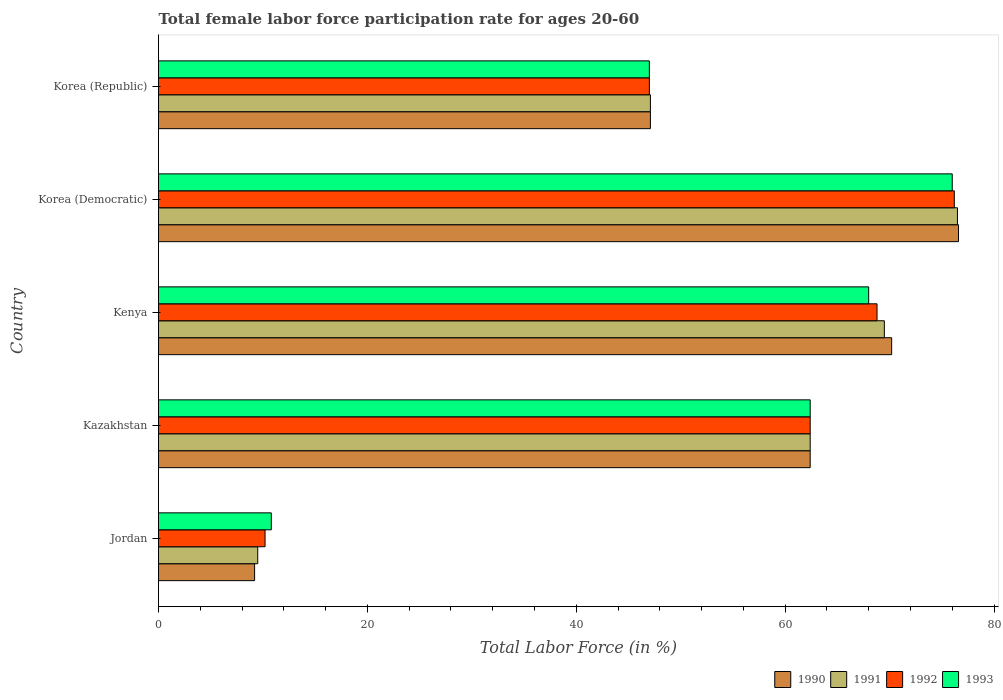How many different coloured bars are there?
Offer a terse response. 4. How many groups of bars are there?
Ensure brevity in your answer.  5. Are the number of bars on each tick of the Y-axis equal?
Give a very brief answer. Yes. How many bars are there on the 3rd tick from the bottom?
Offer a very short reply. 4. What is the label of the 4th group of bars from the top?
Make the answer very short. Kazakhstan. Across all countries, what is the maximum female labor force participation rate in 1991?
Ensure brevity in your answer.  76.5. Across all countries, what is the minimum female labor force participation rate in 1992?
Offer a terse response. 10.2. In which country was the female labor force participation rate in 1990 maximum?
Your response must be concise. Korea (Democratic). In which country was the female labor force participation rate in 1992 minimum?
Offer a terse response. Jordan. What is the total female labor force participation rate in 1991 in the graph?
Provide a succinct answer. 265. What is the difference between the female labor force participation rate in 1991 in Kenya and that in Korea (Republic)?
Give a very brief answer. 22.4. What is the difference between the female labor force participation rate in 1992 in Kenya and the female labor force participation rate in 1990 in Korea (Democratic)?
Make the answer very short. -7.8. What is the average female labor force participation rate in 1993 per country?
Ensure brevity in your answer.  52.84. What is the difference between the female labor force participation rate in 1991 and female labor force participation rate in 1990 in Kenya?
Offer a very short reply. -0.7. In how many countries, is the female labor force participation rate in 1992 greater than 48 %?
Make the answer very short. 3. What is the ratio of the female labor force participation rate in 1993 in Jordan to that in Korea (Republic)?
Keep it short and to the point. 0.23. Is the female labor force participation rate in 1993 in Korea (Democratic) less than that in Korea (Republic)?
Give a very brief answer. No. What is the difference between the highest and the lowest female labor force participation rate in 1993?
Provide a succinct answer. 65.2. In how many countries, is the female labor force participation rate in 1991 greater than the average female labor force participation rate in 1991 taken over all countries?
Your answer should be compact. 3. Is the sum of the female labor force participation rate in 1992 in Kenya and Korea (Democratic) greater than the maximum female labor force participation rate in 1991 across all countries?
Ensure brevity in your answer.  Yes. Is it the case that in every country, the sum of the female labor force participation rate in 1992 and female labor force participation rate in 1991 is greater than the sum of female labor force participation rate in 1993 and female labor force participation rate in 1990?
Make the answer very short. No. Does the graph contain grids?
Your answer should be very brief. No. Where does the legend appear in the graph?
Give a very brief answer. Bottom right. How are the legend labels stacked?
Offer a terse response. Horizontal. What is the title of the graph?
Your response must be concise. Total female labor force participation rate for ages 20-60. What is the label or title of the X-axis?
Keep it short and to the point. Total Labor Force (in %). What is the Total Labor Force (in %) of 1990 in Jordan?
Keep it short and to the point. 9.2. What is the Total Labor Force (in %) of 1992 in Jordan?
Make the answer very short. 10.2. What is the Total Labor Force (in %) of 1993 in Jordan?
Offer a terse response. 10.8. What is the Total Labor Force (in %) in 1990 in Kazakhstan?
Make the answer very short. 62.4. What is the Total Labor Force (in %) of 1991 in Kazakhstan?
Make the answer very short. 62.4. What is the Total Labor Force (in %) of 1992 in Kazakhstan?
Give a very brief answer. 62.4. What is the Total Labor Force (in %) of 1993 in Kazakhstan?
Ensure brevity in your answer.  62.4. What is the Total Labor Force (in %) of 1990 in Kenya?
Make the answer very short. 70.2. What is the Total Labor Force (in %) in 1991 in Kenya?
Give a very brief answer. 69.5. What is the Total Labor Force (in %) in 1992 in Kenya?
Offer a terse response. 68.8. What is the Total Labor Force (in %) in 1993 in Kenya?
Keep it short and to the point. 68. What is the Total Labor Force (in %) of 1990 in Korea (Democratic)?
Provide a succinct answer. 76.6. What is the Total Labor Force (in %) in 1991 in Korea (Democratic)?
Keep it short and to the point. 76.5. What is the Total Labor Force (in %) of 1992 in Korea (Democratic)?
Your response must be concise. 76.2. What is the Total Labor Force (in %) of 1993 in Korea (Democratic)?
Your answer should be very brief. 76. What is the Total Labor Force (in %) of 1990 in Korea (Republic)?
Your response must be concise. 47.1. What is the Total Labor Force (in %) in 1991 in Korea (Republic)?
Offer a very short reply. 47.1. Across all countries, what is the maximum Total Labor Force (in %) of 1990?
Offer a very short reply. 76.6. Across all countries, what is the maximum Total Labor Force (in %) of 1991?
Provide a short and direct response. 76.5. Across all countries, what is the maximum Total Labor Force (in %) in 1992?
Make the answer very short. 76.2. Across all countries, what is the minimum Total Labor Force (in %) of 1990?
Ensure brevity in your answer.  9.2. Across all countries, what is the minimum Total Labor Force (in %) in 1992?
Your answer should be compact. 10.2. Across all countries, what is the minimum Total Labor Force (in %) in 1993?
Offer a very short reply. 10.8. What is the total Total Labor Force (in %) in 1990 in the graph?
Ensure brevity in your answer.  265.5. What is the total Total Labor Force (in %) in 1991 in the graph?
Offer a terse response. 265. What is the total Total Labor Force (in %) of 1992 in the graph?
Your response must be concise. 264.6. What is the total Total Labor Force (in %) of 1993 in the graph?
Make the answer very short. 264.2. What is the difference between the Total Labor Force (in %) in 1990 in Jordan and that in Kazakhstan?
Offer a very short reply. -53.2. What is the difference between the Total Labor Force (in %) in 1991 in Jordan and that in Kazakhstan?
Offer a very short reply. -52.9. What is the difference between the Total Labor Force (in %) in 1992 in Jordan and that in Kazakhstan?
Ensure brevity in your answer.  -52.2. What is the difference between the Total Labor Force (in %) in 1993 in Jordan and that in Kazakhstan?
Give a very brief answer. -51.6. What is the difference between the Total Labor Force (in %) of 1990 in Jordan and that in Kenya?
Offer a very short reply. -61. What is the difference between the Total Labor Force (in %) of 1991 in Jordan and that in Kenya?
Provide a succinct answer. -60. What is the difference between the Total Labor Force (in %) of 1992 in Jordan and that in Kenya?
Your response must be concise. -58.6. What is the difference between the Total Labor Force (in %) of 1993 in Jordan and that in Kenya?
Provide a short and direct response. -57.2. What is the difference between the Total Labor Force (in %) of 1990 in Jordan and that in Korea (Democratic)?
Give a very brief answer. -67.4. What is the difference between the Total Labor Force (in %) of 1991 in Jordan and that in Korea (Democratic)?
Your answer should be very brief. -67. What is the difference between the Total Labor Force (in %) of 1992 in Jordan and that in Korea (Democratic)?
Make the answer very short. -66. What is the difference between the Total Labor Force (in %) in 1993 in Jordan and that in Korea (Democratic)?
Your answer should be very brief. -65.2. What is the difference between the Total Labor Force (in %) of 1990 in Jordan and that in Korea (Republic)?
Your answer should be very brief. -37.9. What is the difference between the Total Labor Force (in %) of 1991 in Jordan and that in Korea (Republic)?
Provide a short and direct response. -37.6. What is the difference between the Total Labor Force (in %) of 1992 in Jordan and that in Korea (Republic)?
Your response must be concise. -36.8. What is the difference between the Total Labor Force (in %) of 1993 in Jordan and that in Korea (Republic)?
Your answer should be compact. -36.2. What is the difference between the Total Labor Force (in %) of 1991 in Kazakhstan and that in Korea (Democratic)?
Offer a very short reply. -14.1. What is the difference between the Total Labor Force (in %) in 1992 in Kazakhstan and that in Korea (Democratic)?
Provide a succinct answer. -13.8. What is the difference between the Total Labor Force (in %) in 1993 in Kazakhstan and that in Korea (Democratic)?
Provide a succinct answer. -13.6. What is the difference between the Total Labor Force (in %) in 1991 in Kazakhstan and that in Korea (Republic)?
Your response must be concise. 15.3. What is the difference between the Total Labor Force (in %) in 1992 in Kazakhstan and that in Korea (Republic)?
Ensure brevity in your answer.  15.4. What is the difference between the Total Labor Force (in %) in 1990 in Kenya and that in Korea (Democratic)?
Your answer should be compact. -6.4. What is the difference between the Total Labor Force (in %) in 1993 in Kenya and that in Korea (Democratic)?
Keep it short and to the point. -8. What is the difference between the Total Labor Force (in %) of 1990 in Kenya and that in Korea (Republic)?
Offer a terse response. 23.1. What is the difference between the Total Labor Force (in %) of 1991 in Kenya and that in Korea (Republic)?
Make the answer very short. 22.4. What is the difference between the Total Labor Force (in %) of 1992 in Kenya and that in Korea (Republic)?
Your answer should be compact. 21.8. What is the difference between the Total Labor Force (in %) of 1990 in Korea (Democratic) and that in Korea (Republic)?
Your answer should be compact. 29.5. What is the difference between the Total Labor Force (in %) of 1991 in Korea (Democratic) and that in Korea (Republic)?
Offer a very short reply. 29.4. What is the difference between the Total Labor Force (in %) in 1992 in Korea (Democratic) and that in Korea (Republic)?
Ensure brevity in your answer.  29.2. What is the difference between the Total Labor Force (in %) of 1993 in Korea (Democratic) and that in Korea (Republic)?
Your answer should be compact. 29. What is the difference between the Total Labor Force (in %) in 1990 in Jordan and the Total Labor Force (in %) in 1991 in Kazakhstan?
Your response must be concise. -53.2. What is the difference between the Total Labor Force (in %) in 1990 in Jordan and the Total Labor Force (in %) in 1992 in Kazakhstan?
Your answer should be very brief. -53.2. What is the difference between the Total Labor Force (in %) in 1990 in Jordan and the Total Labor Force (in %) in 1993 in Kazakhstan?
Ensure brevity in your answer.  -53.2. What is the difference between the Total Labor Force (in %) in 1991 in Jordan and the Total Labor Force (in %) in 1992 in Kazakhstan?
Provide a short and direct response. -52.9. What is the difference between the Total Labor Force (in %) of 1991 in Jordan and the Total Labor Force (in %) of 1993 in Kazakhstan?
Provide a succinct answer. -52.9. What is the difference between the Total Labor Force (in %) in 1992 in Jordan and the Total Labor Force (in %) in 1993 in Kazakhstan?
Offer a terse response. -52.2. What is the difference between the Total Labor Force (in %) of 1990 in Jordan and the Total Labor Force (in %) of 1991 in Kenya?
Keep it short and to the point. -60.3. What is the difference between the Total Labor Force (in %) of 1990 in Jordan and the Total Labor Force (in %) of 1992 in Kenya?
Your response must be concise. -59.6. What is the difference between the Total Labor Force (in %) in 1990 in Jordan and the Total Labor Force (in %) in 1993 in Kenya?
Ensure brevity in your answer.  -58.8. What is the difference between the Total Labor Force (in %) in 1991 in Jordan and the Total Labor Force (in %) in 1992 in Kenya?
Your answer should be compact. -59.3. What is the difference between the Total Labor Force (in %) of 1991 in Jordan and the Total Labor Force (in %) of 1993 in Kenya?
Provide a succinct answer. -58.5. What is the difference between the Total Labor Force (in %) of 1992 in Jordan and the Total Labor Force (in %) of 1993 in Kenya?
Your answer should be very brief. -57.8. What is the difference between the Total Labor Force (in %) of 1990 in Jordan and the Total Labor Force (in %) of 1991 in Korea (Democratic)?
Offer a very short reply. -67.3. What is the difference between the Total Labor Force (in %) in 1990 in Jordan and the Total Labor Force (in %) in 1992 in Korea (Democratic)?
Your response must be concise. -67. What is the difference between the Total Labor Force (in %) of 1990 in Jordan and the Total Labor Force (in %) of 1993 in Korea (Democratic)?
Give a very brief answer. -66.8. What is the difference between the Total Labor Force (in %) of 1991 in Jordan and the Total Labor Force (in %) of 1992 in Korea (Democratic)?
Keep it short and to the point. -66.7. What is the difference between the Total Labor Force (in %) in 1991 in Jordan and the Total Labor Force (in %) in 1993 in Korea (Democratic)?
Give a very brief answer. -66.5. What is the difference between the Total Labor Force (in %) in 1992 in Jordan and the Total Labor Force (in %) in 1993 in Korea (Democratic)?
Ensure brevity in your answer.  -65.8. What is the difference between the Total Labor Force (in %) of 1990 in Jordan and the Total Labor Force (in %) of 1991 in Korea (Republic)?
Your answer should be compact. -37.9. What is the difference between the Total Labor Force (in %) in 1990 in Jordan and the Total Labor Force (in %) in 1992 in Korea (Republic)?
Your response must be concise. -37.8. What is the difference between the Total Labor Force (in %) of 1990 in Jordan and the Total Labor Force (in %) of 1993 in Korea (Republic)?
Your response must be concise. -37.8. What is the difference between the Total Labor Force (in %) in 1991 in Jordan and the Total Labor Force (in %) in 1992 in Korea (Republic)?
Keep it short and to the point. -37.5. What is the difference between the Total Labor Force (in %) of 1991 in Jordan and the Total Labor Force (in %) of 1993 in Korea (Republic)?
Provide a succinct answer. -37.5. What is the difference between the Total Labor Force (in %) in 1992 in Jordan and the Total Labor Force (in %) in 1993 in Korea (Republic)?
Your response must be concise. -36.8. What is the difference between the Total Labor Force (in %) of 1990 in Kazakhstan and the Total Labor Force (in %) of 1992 in Kenya?
Your answer should be compact. -6.4. What is the difference between the Total Labor Force (in %) in 1990 in Kazakhstan and the Total Labor Force (in %) in 1993 in Kenya?
Offer a very short reply. -5.6. What is the difference between the Total Labor Force (in %) of 1991 in Kazakhstan and the Total Labor Force (in %) of 1992 in Kenya?
Offer a terse response. -6.4. What is the difference between the Total Labor Force (in %) in 1992 in Kazakhstan and the Total Labor Force (in %) in 1993 in Kenya?
Ensure brevity in your answer.  -5.6. What is the difference between the Total Labor Force (in %) of 1990 in Kazakhstan and the Total Labor Force (in %) of 1991 in Korea (Democratic)?
Provide a short and direct response. -14.1. What is the difference between the Total Labor Force (in %) of 1991 in Kazakhstan and the Total Labor Force (in %) of 1992 in Korea (Democratic)?
Your answer should be very brief. -13.8. What is the difference between the Total Labor Force (in %) of 1991 in Kazakhstan and the Total Labor Force (in %) of 1993 in Korea (Democratic)?
Provide a succinct answer. -13.6. What is the difference between the Total Labor Force (in %) in 1990 in Kazakhstan and the Total Labor Force (in %) in 1991 in Korea (Republic)?
Your answer should be compact. 15.3. What is the difference between the Total Labor Force (in %) in 1990 in Kazakhstan and the Total Labor Force (in %) in 1992 in Korea (Republic)?
Make the answer very short. 15.4. What is the difference between the Total Labor Force (in %) of 1991 in Kazakhstan and the Total Labor Force (in %) of 1992 in Korea (Republic)?
Your answer should be compact. 15.4. What is the difference between the Total Labor Force (in %) in 1991 in Kazakhstan and the Total Labor Force (in %) in 1993 in Korea (Republic)?
Provide a succinct answer. 15.4. What is the difference between the Total Labor Force (in %) in 1992 in Kazakhstan and the Total Labor Force (in %) in 1993 in Korea (Republic)?
Your response must be concise. 15.4. What is the difference between the Total Labor Force (in %) in 1990 in Kenya and the Total Labor Force (in %) in 1991 in Korea (Democratic)?
Ensure brevity in your answer.  -6.3. What is the difference between the Total Labor Force (in %) in 1990 in Kenya and the Total Labor Force (in %) in 1993 in Korea (Democratic)?
Make the answer very short. -5.8. What is the difference between the Total Labor Force (in %) in 1992 in Kenya and the Total Labor Force (in %) in 1993 in Korea (Democratic)?
Keep it short and to the point. -7.2. What is the difference between the Total Labor Force (in %) in 1990 in Kenya and the Total Labor Force (in %) in 1991 in Korea (Republic)?
Ensure brevity in your answer.  23.1. What is the difference between the Total Labor Force (in %) of 1990 in Kenya and the Total Labor Force (in %) of 1992 in Korea (Republic)?
Provide a short and direct response. 23.2. What is the difference between the Total Labor Force (in %) of 1990 in Kenya and the Total Labor Force (in %) of 1993 in Korea (Republic)?
Provide a short and direct response. 23.2. What is the difference between the Total Labor Force (in %) of 1991 in Kenya and the Total Labor Force (in %) of 1992 in Korea (Republic)?
Ensure brevity in your answer.  22.5. What is the difference between the Total Labor Force (in %) of 1991 in Kenya and the Total Labor Force (in %) of 1993 in Korea (Republic)?
Provide a short and direct response. 22.5. What is the difference between the Total Labor Force (in %) of 1992 in Kenya and the Total Labor Force (in %) of 1993 in Korea (Republic)?
Make the answer very short. 21.8. What is the difference between the Total Labor Force (in %) of 1990 in Korea (Democratic) and the Total Labor Force (in %) of 1991 in Korea (Republic)?
Offer a terse response. 29.5. What is the difference between the Total Labor Force (in %) in 1990 in Korea (Democratic) and the Total Labor Force (in %) in 1992 in Korea (Republic)?
Give a very brief answer. 29.6. What is the difference between the Total Labor Force (in %) in 1990 in Korea (Democratic) and the Total Labor Force (in %) in 1993 in Korea (Republic)?
Ensure brevity in your answer.  29.6. What is the difference between the Total Labor Force (in %) of 1991 in Korea (Democratic) and the Total Labor Force (in %) of 1992 in Korea (Republic)?
Your response must be concise. 29.5. What is the difference between the Total Labor Force (in %) of 1991 in Korea (Democratic) and the Total Labor Force (in %) of 1993 in Korea (Republic)?
Your response must be concise. 29.5. What is the difference between the Total Labor Force (in %) of 1992 in Korea (Democratic) and the Total Labor Force (in %) of 1993 in Korea (Republic)?
Give a very brief answer. 29.2. What is the average Total Labor Force (in %) of 1990 per country?
Provide a short and direct response. 53.1. What is the average Total Labor Force (in %) in 1992 per country?
Ensure brevity in your answer.  52.92. What is the average Total Labor Force (in %) in 1993 per country?
Ensure brevity in your answer.  52.84. What is the difference between the Total Labor Force (in %) of 1990 and Total Labor Force (in %) of 1991 in Jordan?
Offer a terse response. -0.3. What is the difference between the Total Labor Force (in %) of 1990 and Total Labor Force (in %) of 1993 in Jordan?
Ensure brevity in your answer.  -1.6. What is the difference between the Total Labor Force (in %) in 1991 and Total Labor Force (in %) in 1992 in Jordan?
Provide a succinct answer. -0.7. What is the difference between the Total Labor Force (in %) of 1990 and Total Labor Force (in %) of 1992 in Kazakhstan?
Provide a succinct answer. 0. What is the difference between the Total Labor Force (in %) of 1990 and Total Labor Force (in %) of 1993 in Kazakhstan?
Give a very brief answer. 0. What is the difference between the Total Labor Force (in %) of 1991 and Total Labor Force (in %) of 1992 in Kazakhstan?
Your answer should be very brief. 0. What is the difference between the Total Labor Force (in %) of 1991 and Total Labor Force (in %) of 1993 in Kazakhstan?
Your answer should be very brief. 0. What is the difference between the Total Labor Force (in %) in 1990 and Total Labor Force (in %) in 1991 in Kenya?
Ensure brevity in your answer.  0.7. What is the difference between the Total Labor Force (in %) of 1990 and Total Labor Force (in %) of 1992 in Kenya?
Offer a terse response. 1.4. What is the difference between the Total Labor Force (in %) of 1990 and Total Labor Force (in %) of 1993 in Kenya?
Give a very brief answer. 2.2. What is the difference between the Total Labor Force (in %) in 1991 and Total Labor Force (in %) in 1992 in Kenya?
Give a very brief answer. 0.7. What is the difference between the Total Labor Force (in %) in 1992 and Total Labor Force (in %) in 1993 in Kenya?
Give a very brief answer. 0.8. What is the difference between the Total Labor Force (in %) in 1990 and Total Labor Force (in %) in 1992 in Korea (Democratic)?
Keep it short and to the point. 0.4. What is the difference between the Total Labor Force (in %) of 1990 and Total Labor Force (in %) of 1993 in Korea (Democratic)?
Your answer should be very brief. 0.6. What is the difference between the Total Labor Force (in %) in 1990 and Total Labor Force (in %) in 1991 in Korea (Republic)?
Offer a terse response. 0. What is the difference between the Total Labor Force (in %) in 1990 and Total Labor Force (in %) in 1993 in Korea (Republic)?
Your response must be concise. 0.1. What is the difference between the Total Labor Force (in %) of 1991 and Total Labor Force (in %) of 1992 in Korea (Republic)?
Give a very brief answer. 0.1. What is the ratio of the Total Labor Force (in %) of 1990 in Jordan to that in Kazakhstan?
Offer a terse response. 0.15. What is the ratio of the Total Labor Force (in %) in 1991 in Jordan to that in Kazakhstan?
Your response must be concise. 0.15. What is the ratio of the Total Labor Force (in %) in 1992 in Jordan to that in Kazakhstan?
Provide a short and direct response. 0.16. What is the ratio of the Total Labor Force (in %) of 1993 in Jordan to that in Kazakhstan?
Give a very brief answer. 0.17. What is the ratio of the Total Labor Force (in %) of 1990 in Jordan to that in Kenya?
Provide a short and direct response. 0.13. What is the ratio of the Total Labor Force (in %) of 1991 in Jordan to that in Kenya?
Provide a short and direct response. 0.14. What is the ratio of the Total Labor Force (in %) in 1992 in Jordan to that in Kenya?
Provide a succinct answer. 0.15. What is the ratio of the Total Labor Force (in %) in 1993 in Jordan to that in Kenya?
Your answer should be very brief. 0.16. What is the ratio of the Total Labor Force (in %) of 1990 in Jordan to that in Korea (Democratic)?
Ensure brevity in your answer.  0.12. What is the ratio of the Total Labor Force (in %) of 1991 in Jordan to that in Korea (Democratic)?
Keep it short and to the point. 0.12. What is the ratio of the Total Labor Force (in %) in 1992 in Jordan to that in Korea (Democratic)?
Provide a short and direct response. 0.13. What is the ratio of the Total Labor Force (in %) in 1993 in Jordan to that in Korea (Democratic)?
Your response must be concise. 0.14. What is the ratio of the Total Labor Force (in %) in 1990 in Jordan to that in Korea (Republic)?
Provide a short and direct response. 0.2. What is the ratio of the Total Labor Force (in %) in 1991 in Jordan to that in Korea (Republic)?
Provide a short and direct response. 0.2. What is the ratio of the Total Labor Force (in %) in 1992 in Jordan to that in Korea (Republic)?
Provide a short and direct response. 0.22. What is the ratio of the Total Labor Force (in %) of 1993 in Jordan to that in Korea (Republic)?
Make the answer very short. 0.23. What is the ratio of the Total Labor Force (in %) in 1991 in Kazakhstan to that in Kenya?
Ensure brevity in your answer.  0.9. What is the ratio of the Total Labor Force (in %) of 1992 in Kazakhstan to that in Kenya?
Give a very brief answer. 0.91. What is the ratio of the Total Labor Force (in %) in 1993 in Kazakhstan to that in Kenya?
Make the answer very short. 0.92. What is the ratio of the Total Labor Force (in %) in 1990 in Kazakhstan to that in Korea (Democratic)?
Offer a very short reply. 0.81. What is the ratio of the Total Labor Force (in %) of 1991 in Kazakhstan to that in Korea (Democratic)?
Make the answer very short. 0.82. What is the ratio of the Total Labor Force (in %) in 1992 in Kazakhstan to that in Korea (Democratic)?
Keep it short and to the point. 0.82. What is the ratio of the Total Labor Force (in %) of 1993 in Kazakhstan to that in Korea (Democratic)?
Ensure brevity in your answer.  0.82. What is the ratio of the Total Labor Force (in %) in 1990 in Kazakhstan to that in Korea (Republic)?
Your response must be concise. 1.32. What is the ratio of the Total Labor Force (in %) in 1991 in Kazakhstan to that in Korea (Republic)?
Keep it short and to the point. 1.32. What is the ratio of the Total Labor Force (in %) in 1992 in Kazakhstan to that in Korea (Republic)?
Make the answer very short. 1.33. What is the ratio of the Total Labor Force (in %) in 1993 in Kazakhstan to that in Korea (Republic)?
Offer a very short reply. 1.33. What is the ratio of the Total Labor Force (in %) in 1990 in Kenya to that in Korea (Democratic)?
Give a very brief answer. 0.92. What is the ratio of the Total Labor Force (in %) of 1991 in Kenya to that in Korea (Democratic)?
Your answer should be compact. 0.91. What is the ratio of the Total Labor Force (in %) of 1992 in Kenya to that in Korea (Democratic)?
Keep it short and to the point. 0.9. What is the ratio of the Total Labor Force (in %) in 1993 in Kenya to that in Korea (Democratic)?
Your answer should be compact. 0.89. What is the ratio of the Total Labor Force (in %) of 1990 in Kenya to that in Korea (Republic)?
Provide a short and direct response. 1.49. What is the ratio of the Total Labor Force (in %) of 1991 in Kenya to that in Korea (Republic)?
Give a very brief answer. 1.48. What is the ratio of the Total Labor Force (in %) of 1992 in Kenya to that in Korea (Republic)?
Offer a very short reply. 1.46. What is the ratio of the Total Labor Force (in %) of 1993 in Kenya to that in Korea (Republic)?
Your answer should be very brief. 1.45. What is the ratio of the Total Labor Force (in %) of 1990 in Korea (Democratic) to that in Korea (Republic)?
Provide a succinct answer. 1.63. What is the ratio of the Total Labor Force (in %) in 1991 in Korea (Democratic) to that in Korea (Republic)?
Provide a succinct answer. 1.62. What is the ratio of the Total Labor Force (in %) in 1992 in Korea (Democratic) to that in Korea (Republic)?
Keep it short and to the point. 1.62. What is the ratio of the Total Labor Force (in %) of 1993 in Korea (Democratic) to that in Korea (Republic)?
Your answer should be very brief. 1.62. What is the difference between the highest and the second highest Total Labor Force (in %) of 1990?
Keep it short and to the point. 6.4. What is the difference between the highest and the second highest Total Labor Force (in %) of 1991?
Provide a succinct answer. 7. What is the difference between the highest and the lowest Total Labor Force (in %) of 1990?
Provide a succinct answer. 67.4. What is the difference between the highest and the lowest Total Labor Force (in %) in 1991?
Make the answer very short. 67. What is the difference between the highest and the lowest Total Labor Force (in %) of 1992?
Provide a short and direct response. 66. What is the difference between the highest and the lowest Total Labor Force (in %) of 1993?
Provide a succinct answer. 65.2. 